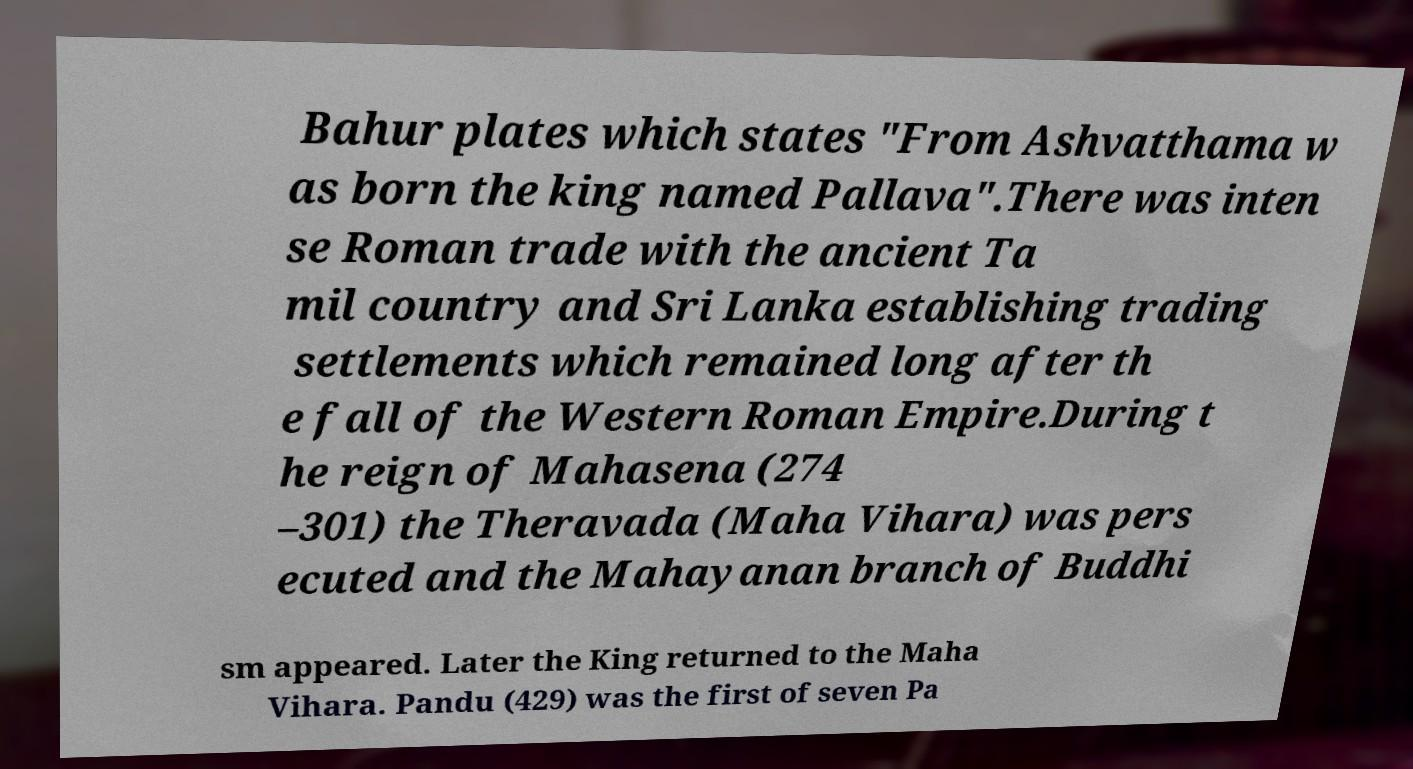What messages or text are displayed in this image? I need them in a readable, typed format. Bahur plates which states "From Ashvatthama w as born the king named Pallava".There was inten se Roman trade with the ancient Ta mil country and Sri Lanka establishing trading settlements which remained long after th e fall of the Western Roman Empire.During t he reign of Mahasena (274 –301) the Theravada (Maha Vihara) was pers ecuted and the Mahayanan branch of Buddhi sm appeared. Later the King returned to the Maha Vihara. Pandu (429) was the first of seven Pa 